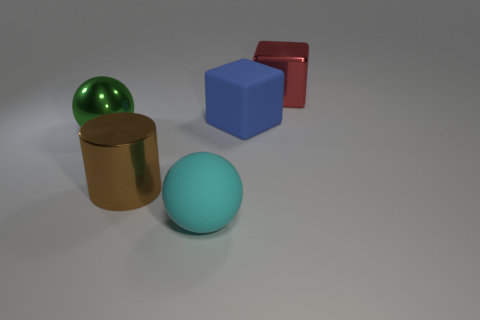The large sphere that is made of the same material as the red thing is what color? Based on the image, the large sphere shares the same specular and reflective qualities as the object that appears red. Given these properties and their similar appearance, we can determine that the large sphere is indeed green in color. This observation suggests that they may be made from the same type of reflective material, which tends to change appearance depending on the viewing angle and lighting conditions. 